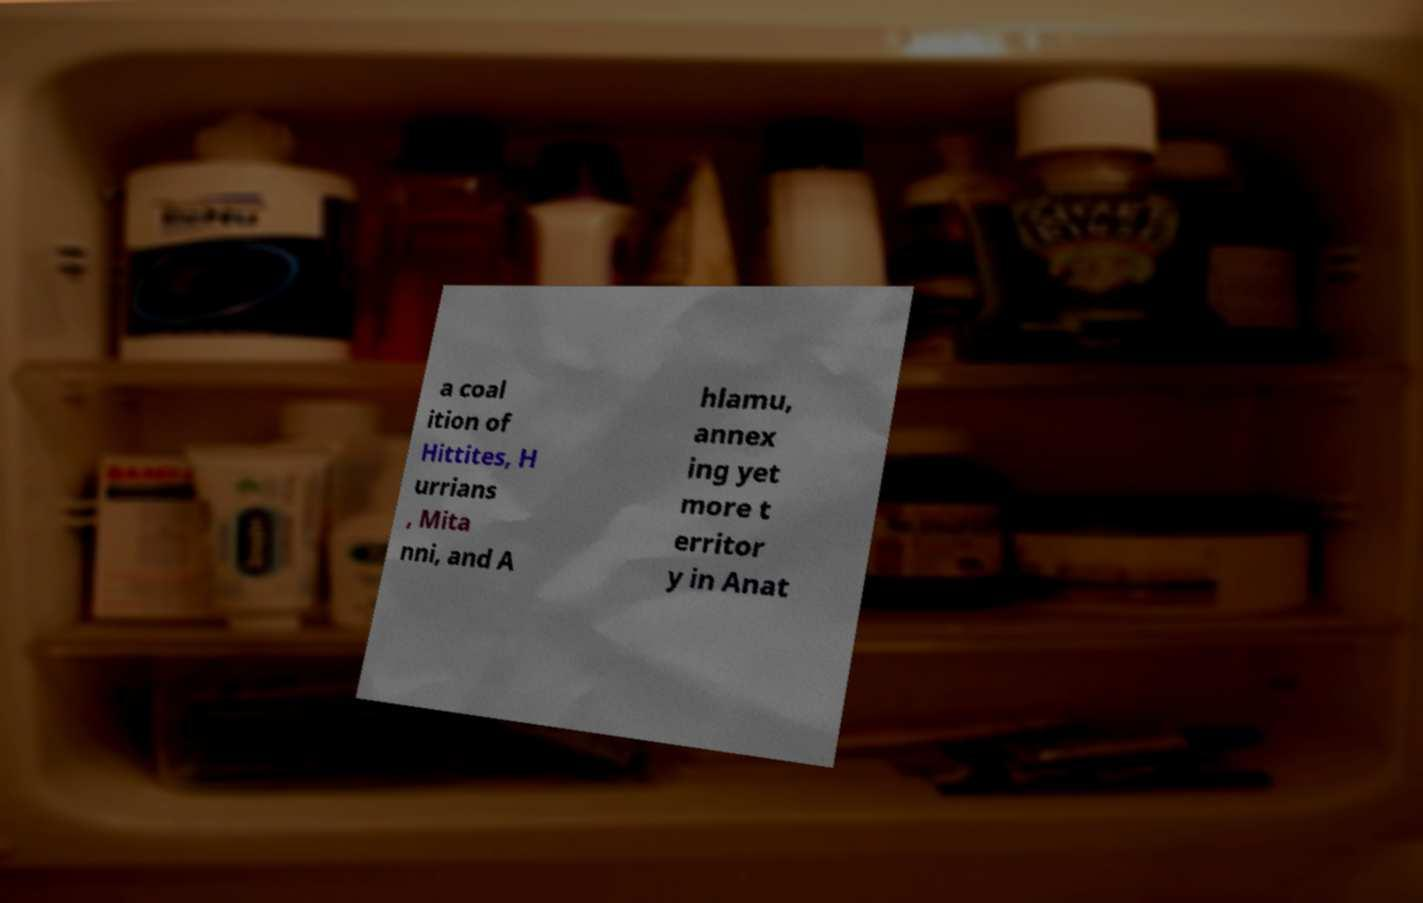Please identify and transcribe the text found in this image. a coal ition of Hittites, H urrians , Mita nni, and A hlamu, annex ing yet more t erritor y in Anat 